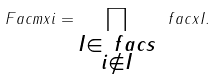<formula> <loc_0><loc_0><loc_500><loc_500>\ F a c m x { i } = \prod _ { \substack { I \in \ f a c s \\ i \not \in I } } \ f a c x { I } .</formula> 